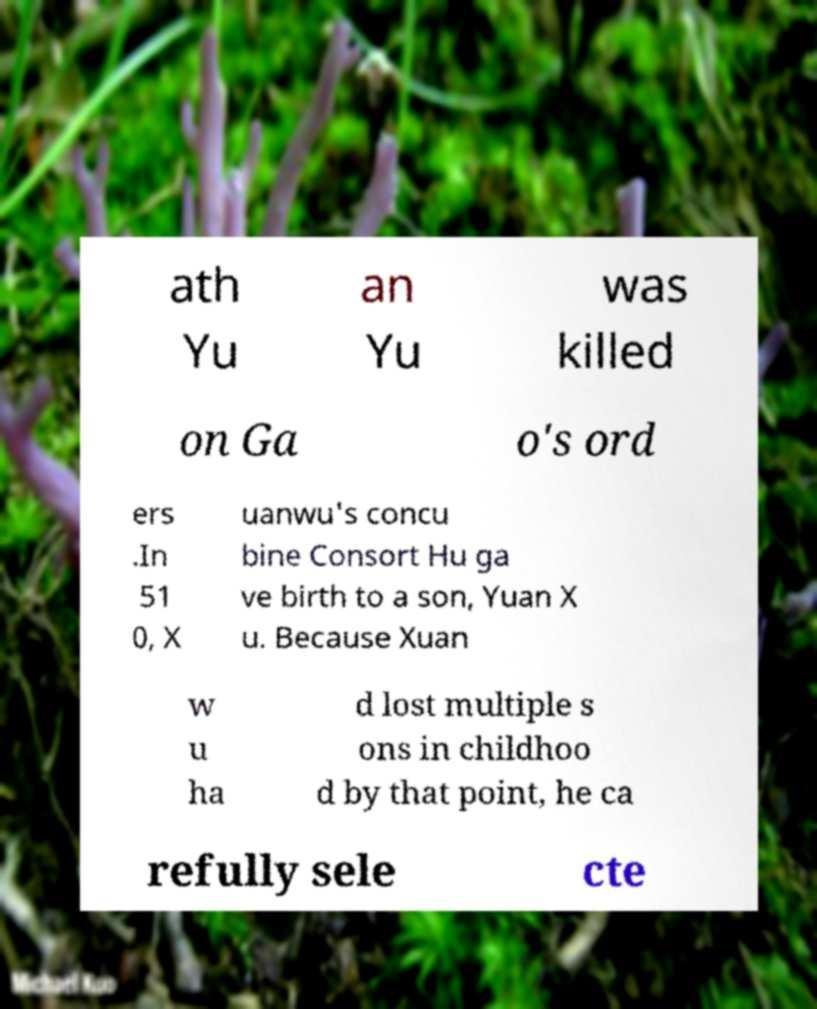Please identify and transcribe the text found in this image. ath Yu an Yu was killed on Ga o's ord ers .In 51 0, X uanwu's concu bine Consort Hu ga ve birth to a son, Yuan X u. Because Xuan w u ha d lost multiple s ons in childhoo d by that point, he ca refully sele cte 